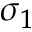Convert formula to latex. <formula><loc_0><loc_0><loc_500><loc_500>\sigma _ { 1 }</formula> 